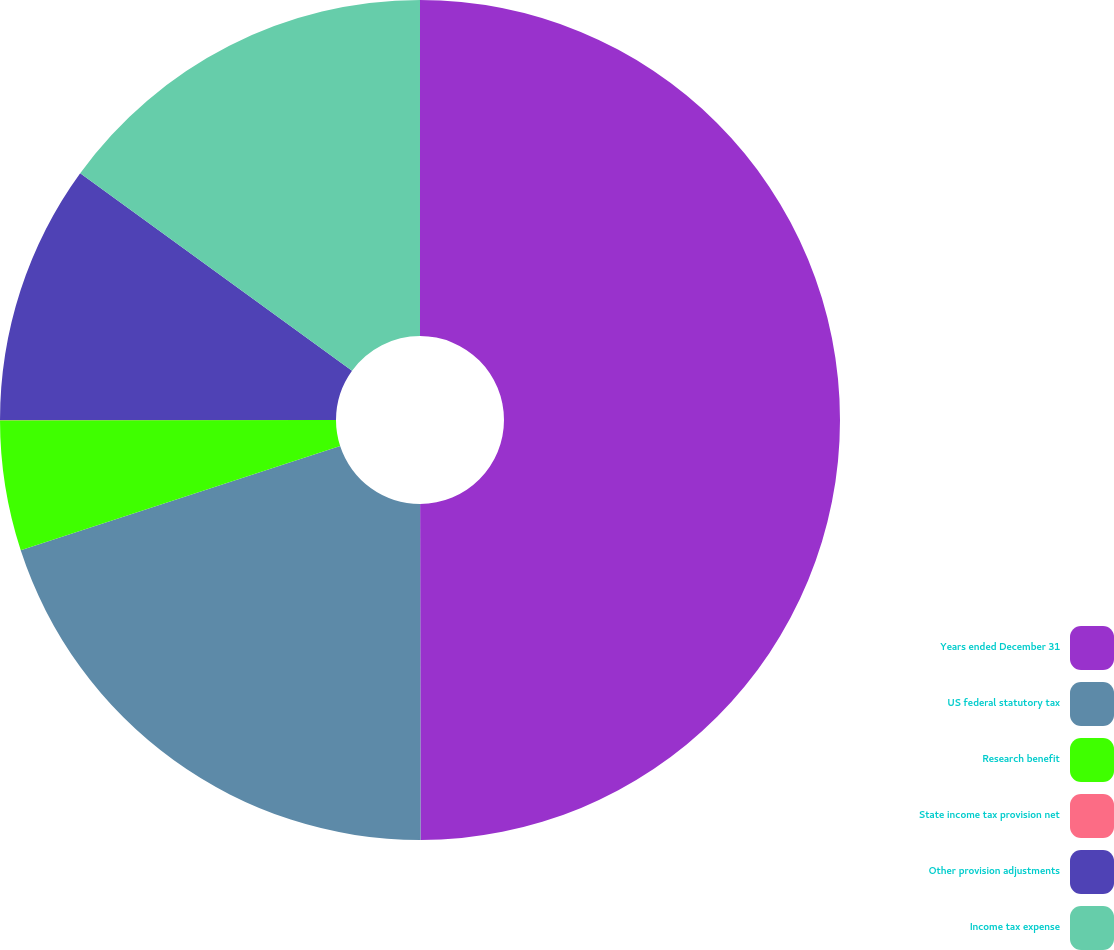Convert chart to OTSL. <chart><loc_0><loc_0><loc_500><loc_500><pie_chart><fcel>Years ended December 31<fcel>US federal statutory tax<fcel>Research benefit<fcel>State income tax provision net<fcel>Other provision adjustments<fcel>Income tax expense<nl><fcel>49.98%<fcel>20.0%<fcel>5.01%<fcel>0.01%<fcel>10.0%<fcel>15.0%<nl></chart> 